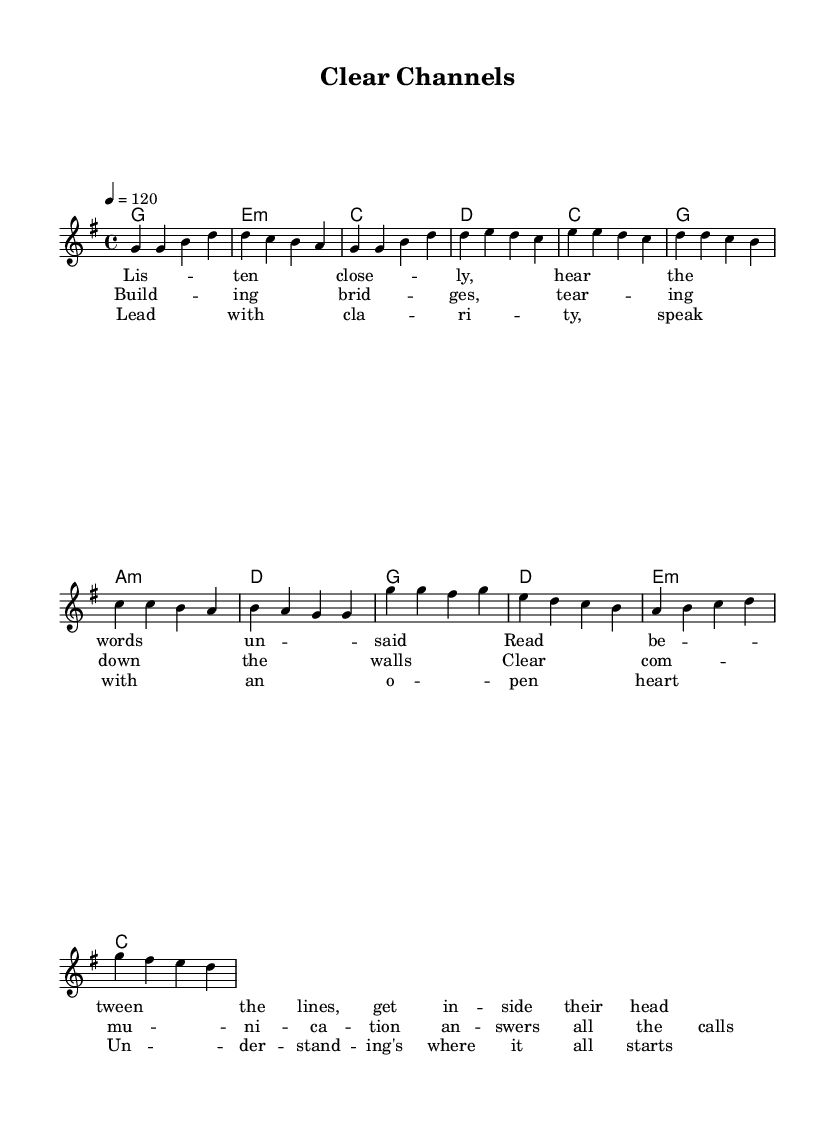What is the key signature of this music? The key signature indicates G major, which has one sharp (F#). This is gathered from the global settings where "\key g \major" is defined.
Answer: G major What is the time signature of this piece? The time signature is 4/4, indicating four beats per measure and a quarter note gets one beat. This is shown in the global settings with "\time 4/4".
Answer: 4/4 What is the tempo marking for this composition? The tempo marking is set to 120 beats per minute, as specified by “\tempo 4 = 120” in the global settings.
Answer: 120 How many measures are in the verse section? The verse consists of four measures as counted from the melody notation where the verse notes are organized into four bars.
Answer: 4 How many unique chords are played in the chorus? The chorus contains four unique chords: G, D, E minor, and C. These are identified in the harmonies section corresponding to the chorus melody.
Answer: 4 What is the main theme of the lyrics in the pre-chorus? The pre-chorus lyrics focus on building connections and effective communication, as indicated by phrases about "bridges" and "tearing down walls". The reasoning comes from analyzing the lyrical content provided in the pre-chorus section.
Answer: Communication What is the primary melodic contour of the chorus? The primary contour of the chorus features a rising and falling pattern that starts high with G and drops down in pitch, creating an emotionally engaging effect commonly found in pop music. This is observed by examining the sequence of notes played in the chorus melody.
Answer: Rising and falling 